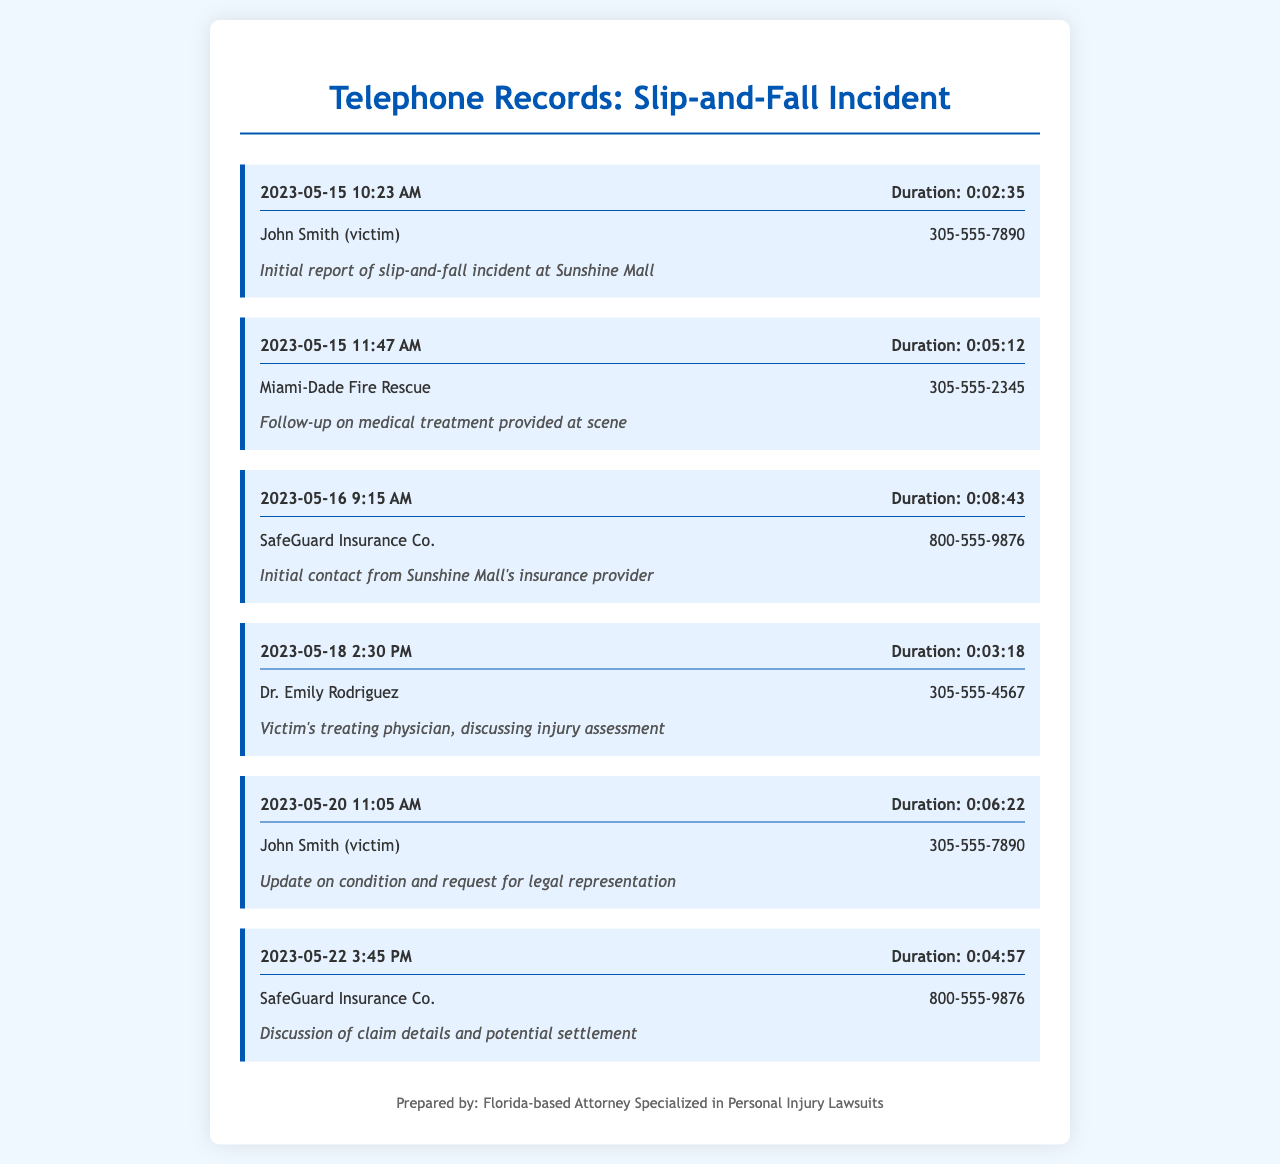What date was the initial report of the incident made? The initial report of the slip-and-fall incident was made on May 15, 2023.
Answer: May 15, 2023 Who was the treating physician mentioned in the records? Dr. Emily Rodriguez is the treating physician discussed in the telephone records.
Answer: Dr. Emily Rodriguez What was the duration of the call with Miami-Dade Fire Rescue? The duration of the call with Miami-Dade Fire Rescue was 5 minutes and 12 seconds.
Answer: 0:05:12 When did the victim contact SafeGuard Insurance Co. for the first time? The victim contacted SafeGuard Insurance Co. on May 16, 2023.
Answer: May 16, 2023 What is the phone number of SafeGuard Insurance Co.? The phone number for SafeGuard Insurance Co. is 800-555-9876.
Answer: 800-555-9876 What was discussed during the call on May 22, 2023? The discussion on May 22, 2023, was about claim details and potential settlement.
Answer: Claim details and potential settlement What type of incident is reported in the telephone records? The incident type reported is a slip-and-fall incident.
Answer: Slip-and-fall How long after the initial incident report did the victim contact their doctor? The victim contacted their doctor on May 18, 2023, which is 3 days after the initial incident report.
Answer: 3 days What time was the last recorded contact with SafeGuard Insurance Co.? The last recorded contact with SafeGuard Insurance Co. was at 3:45 PM.
Answer: 3:45 PM 